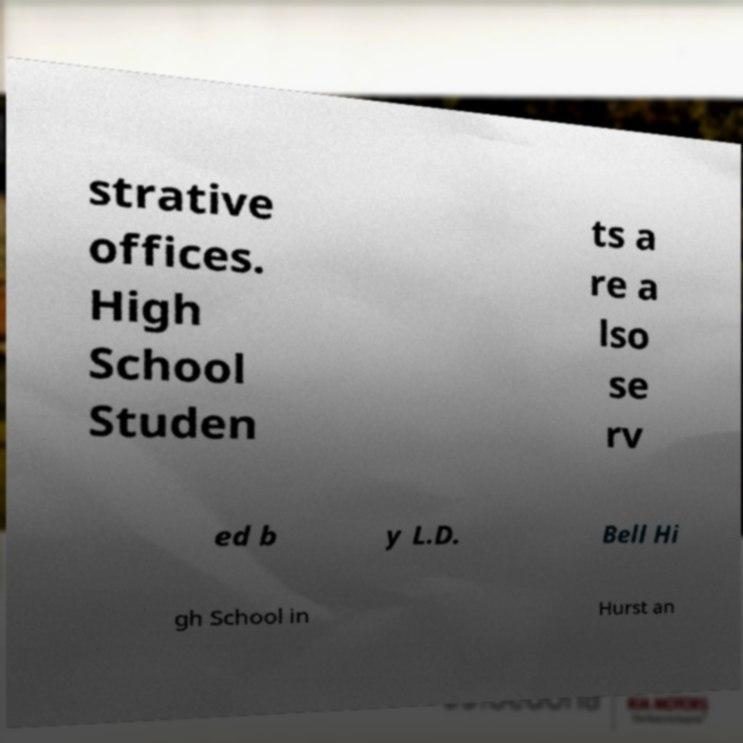Could you extract and type out the text from this image? strative offices. High School Studen ts a re a lso se rv ed b y L.D. Bell Hi gh School in Hurst an 